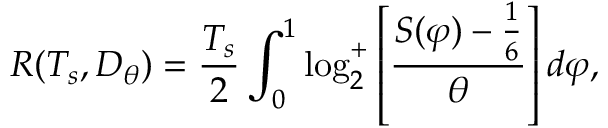<formula> <loc_0><loc_0><loc_500><loc_500>R ( T _ { s } , D _ { \theta } ) = { \frac { T _ { s } } { 2 } } \int _ { 0 } ^ { 1 } \log _ { 2 } ^ { + } \left [ { \frac { S ( \varphi ) - { \frac { 1 } { 6 } } } { \theta } } \right ] d \varphi ,</formula> 